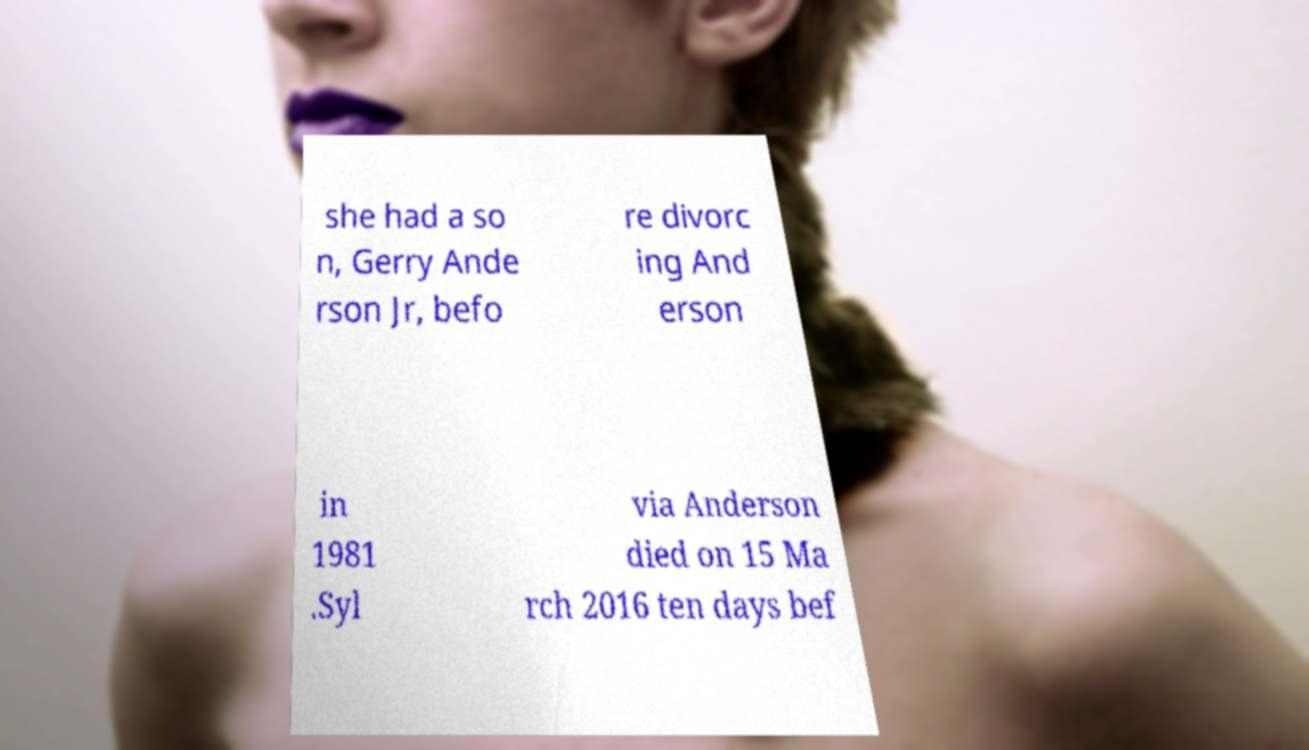I need the written content from this picture converted into text. Can you do that? she had a so n, Gerry Ande rson Jr, befo re divorc ing And erson in 1981 .Syl via Anderson died on 15 Ma rch 2016 ten days bef 